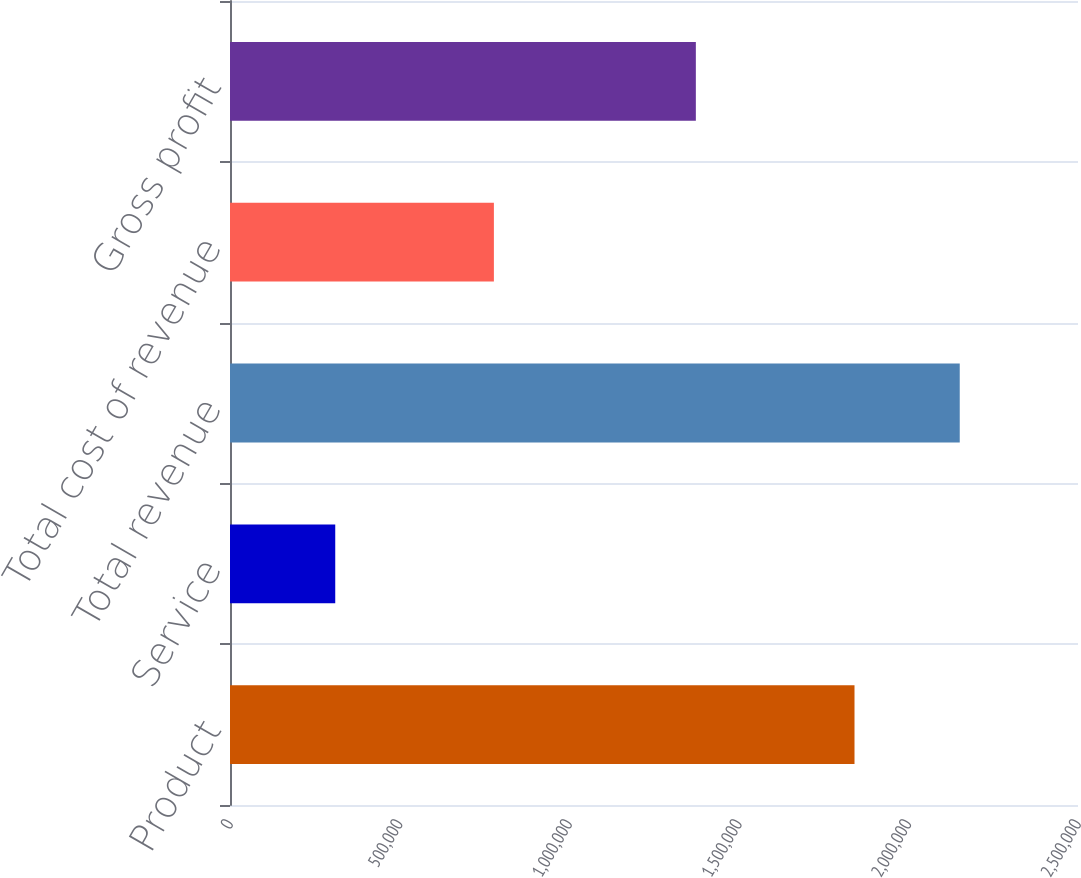<chart> <loc_0><loc_0><loc_500><loc_500><bar_chart><fcel>Product<fcel>Service<fcel>Total revenue<fcel>Total cost of revenue<fcel>Gross profit<nl><fcel>1.8411e+06<fcel>310269<fcel>2.15137e+06<fcel>777992<fcel>1.37338e+06<nl></chart> 